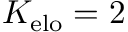Convert formula to latex. <formula><loc_0><loc_0><loc_500><loc_500>K _ { e l o } = 2</formula> 